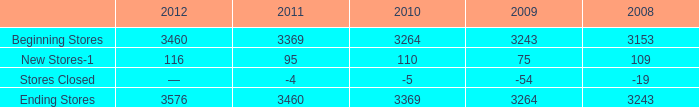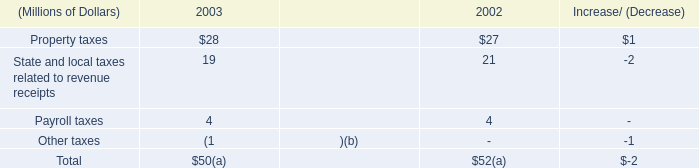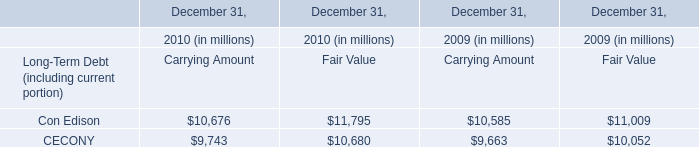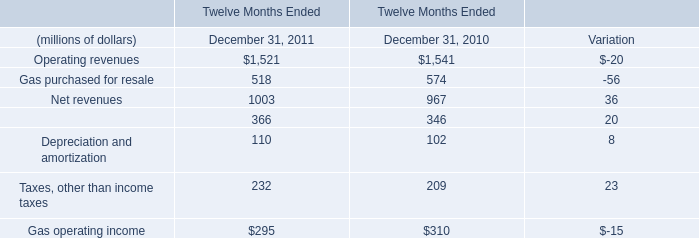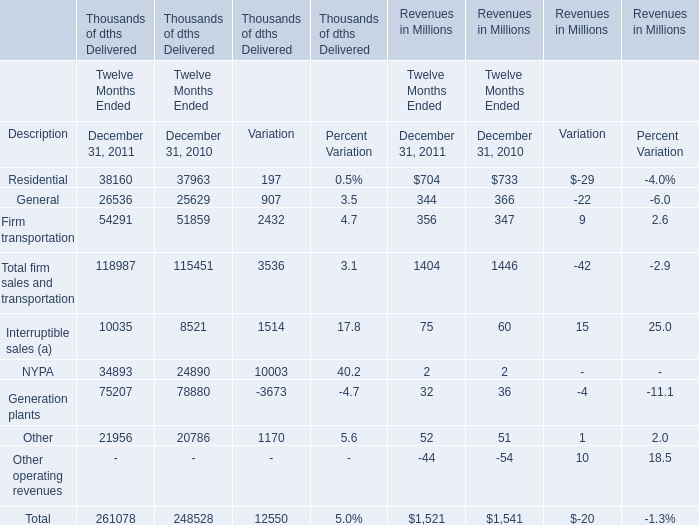In which year is Revenues of General greater than Revenues of Firm transportation? 
Answer: 2010. 